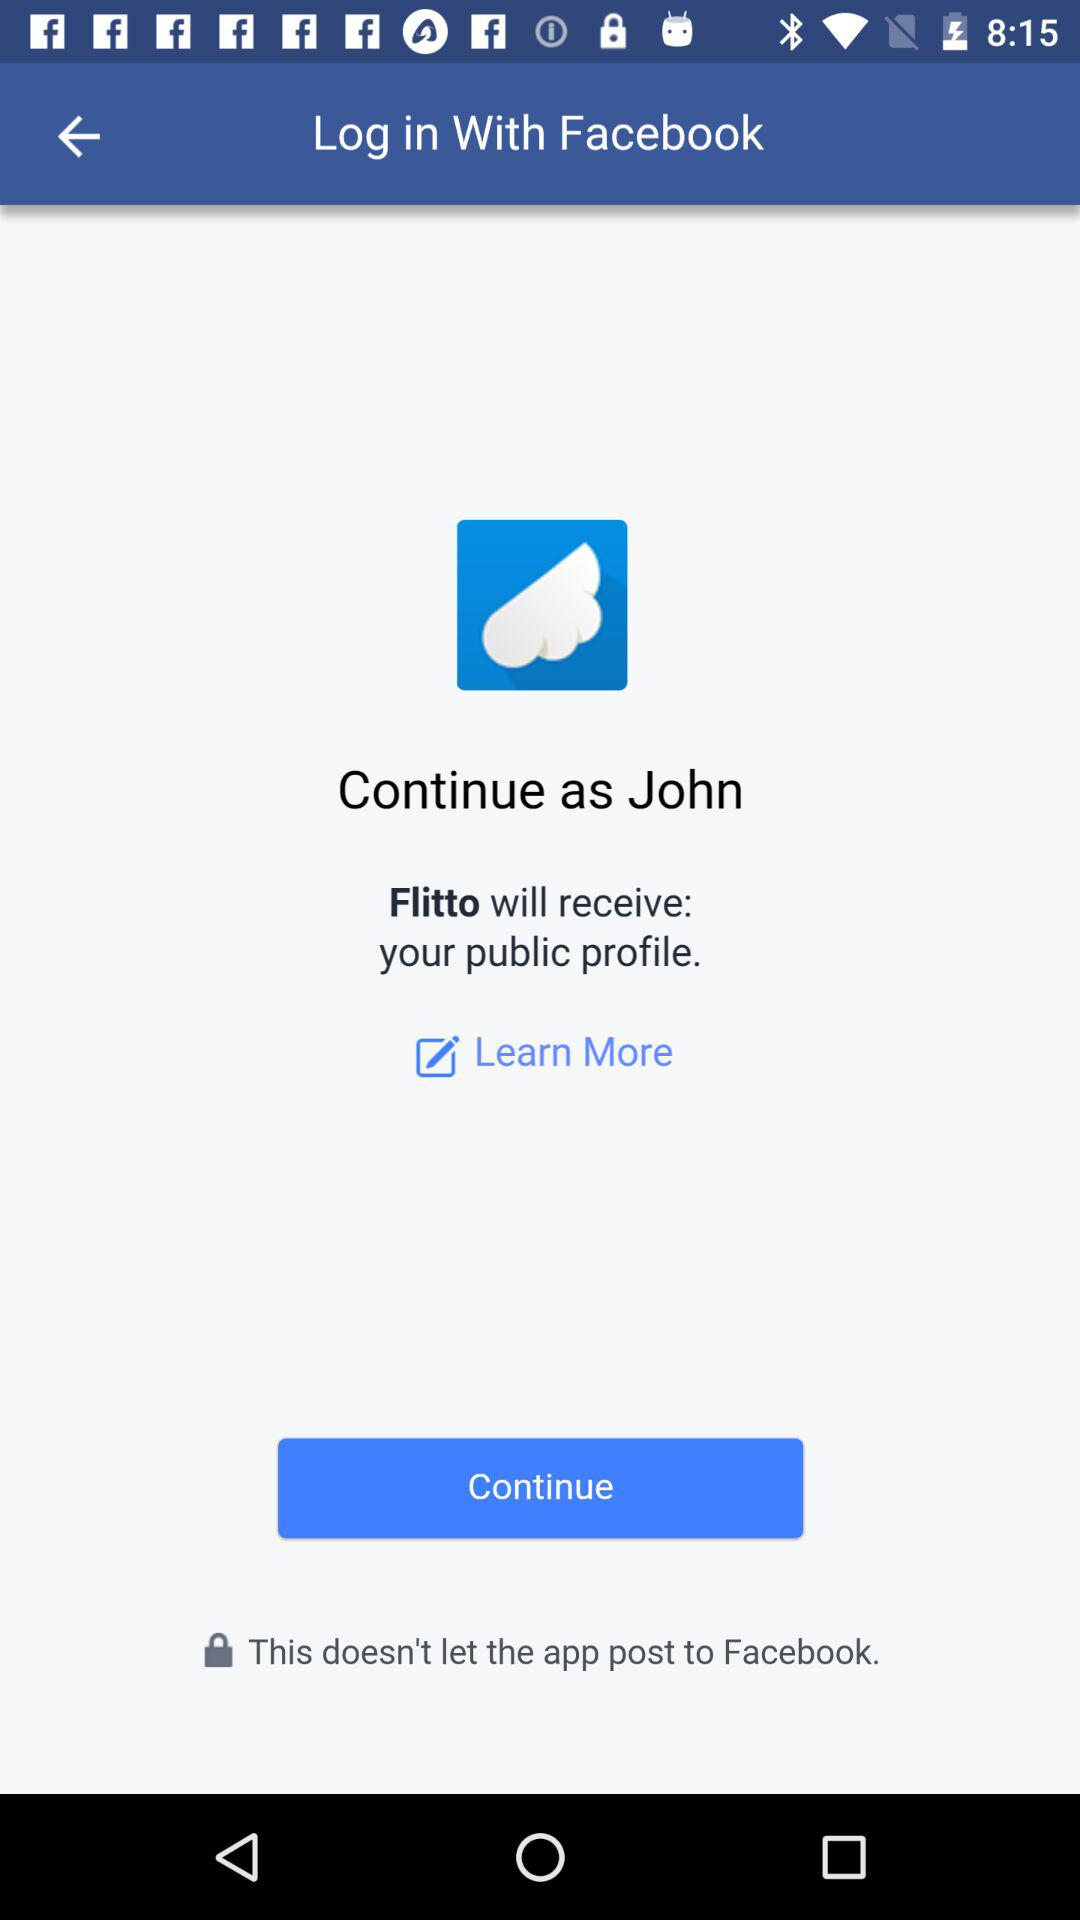What is the name of the user? The name of the user is John. 